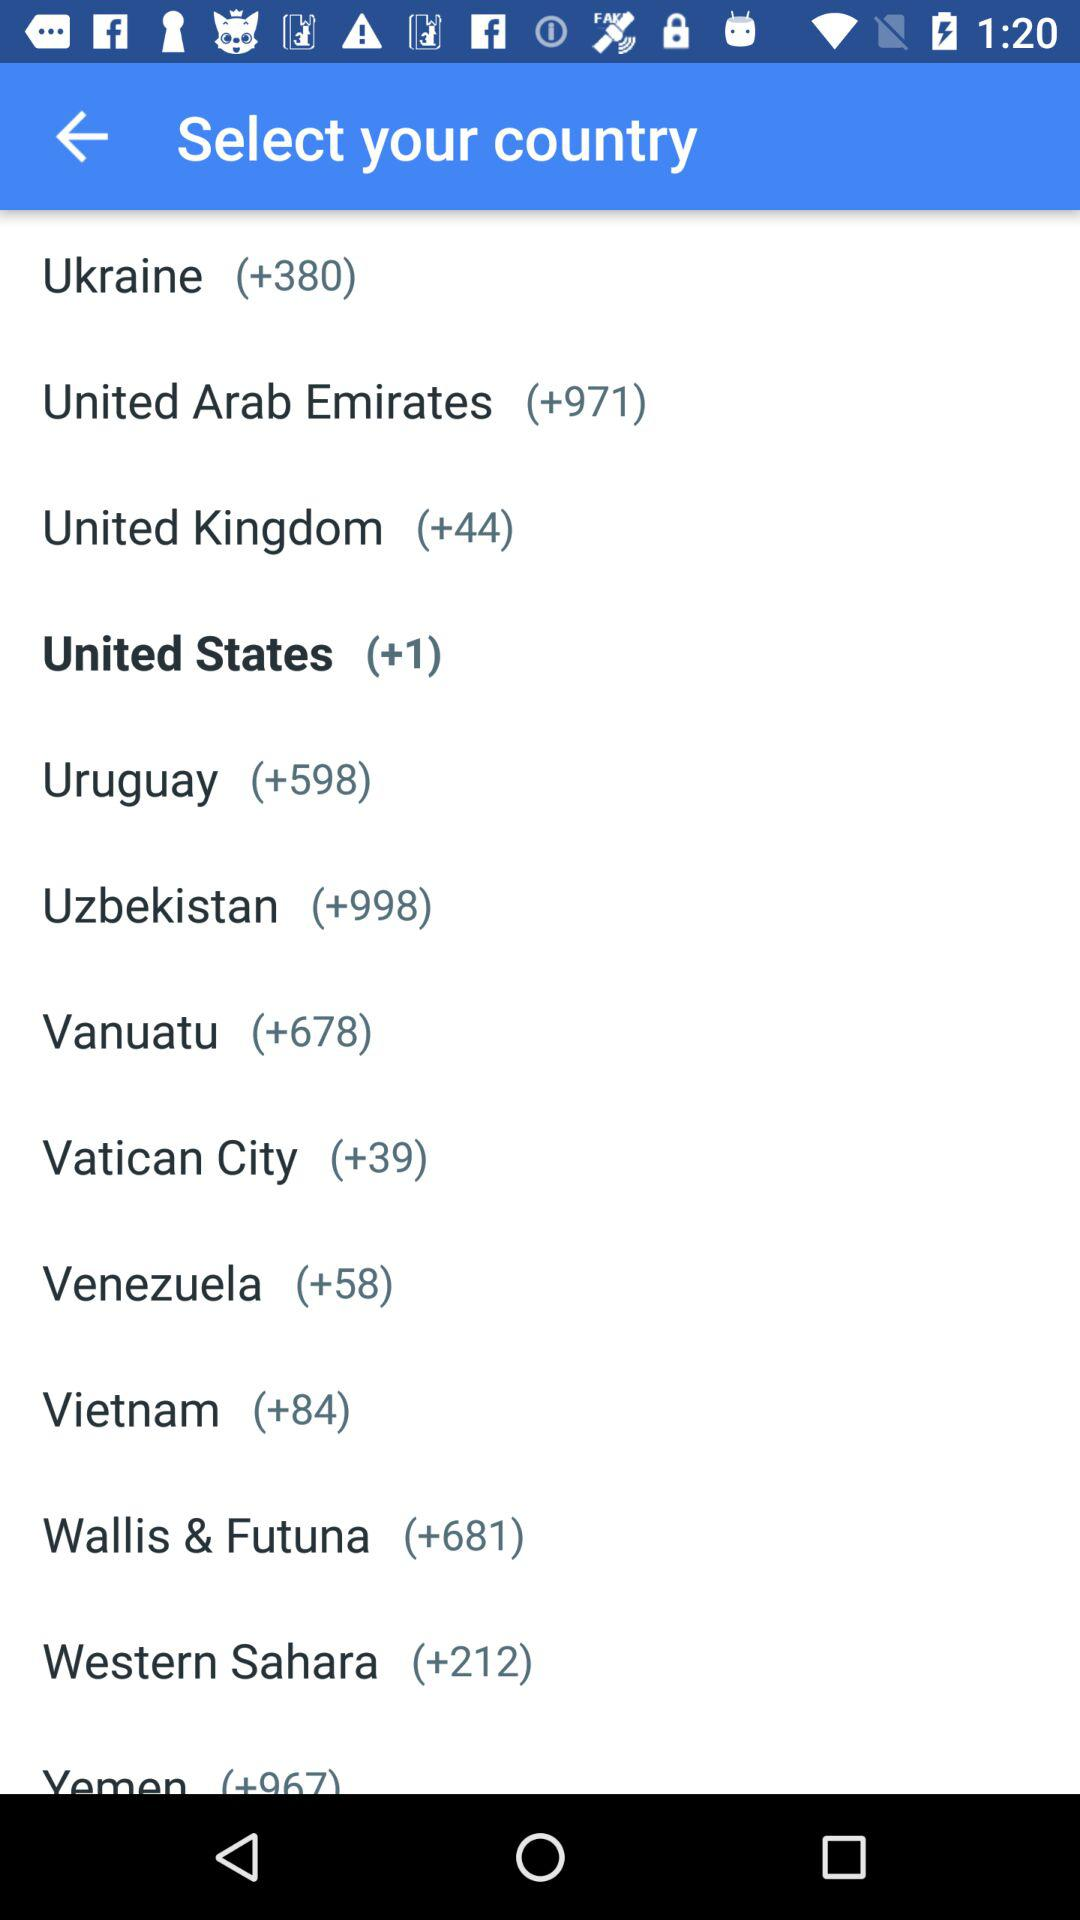What is the name of the country having a country code of +44? The name of the country is "United Kingdom". 